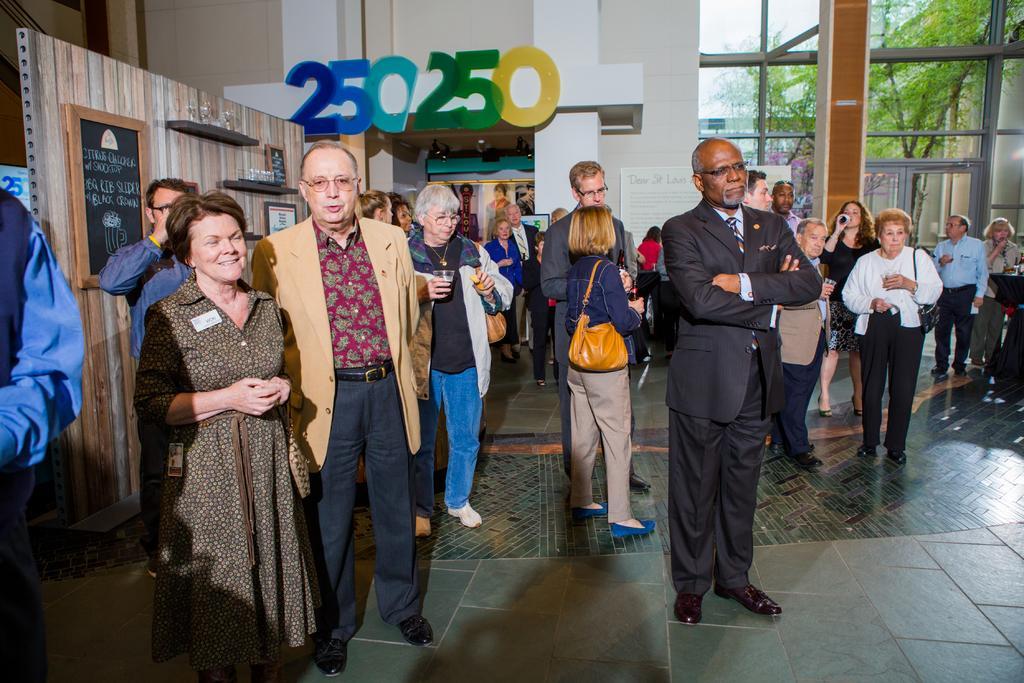Please provide a concise description of this image. The picture is taken inside a building. In this picture there are men and women standing. On the left there is a wooden wall, to the there are boards, cupboards, in the cupboards there are glasses and other objects. In the center of the background there are numbers, frames and other objects. In the background there are glass windows, outside the windows there are trees. 